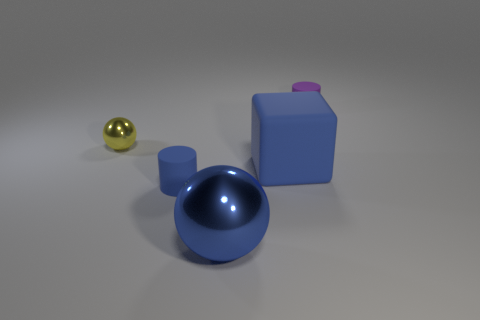Subtract 2 spheres. How many spheres are left? 0 Add 2 big red rubber cylinders. How many objects exist? 7 Subtract all small things. Subtract all blue cubes. How many objects are left? 1 Add 1 large blocks. How many large blocks are left? 2 Add 4 large rubber cubes. How many large rubber cubes exist? 5 Subtract 0 red cylinders. How many objects are left? 5 Subtract all spheres. How many objects are left? 3 Subtract all red blocks. Subtract all purple balls. How many blocks are left? 1 Subtract all purple cylinders. How many yellow spheres are left? 1 